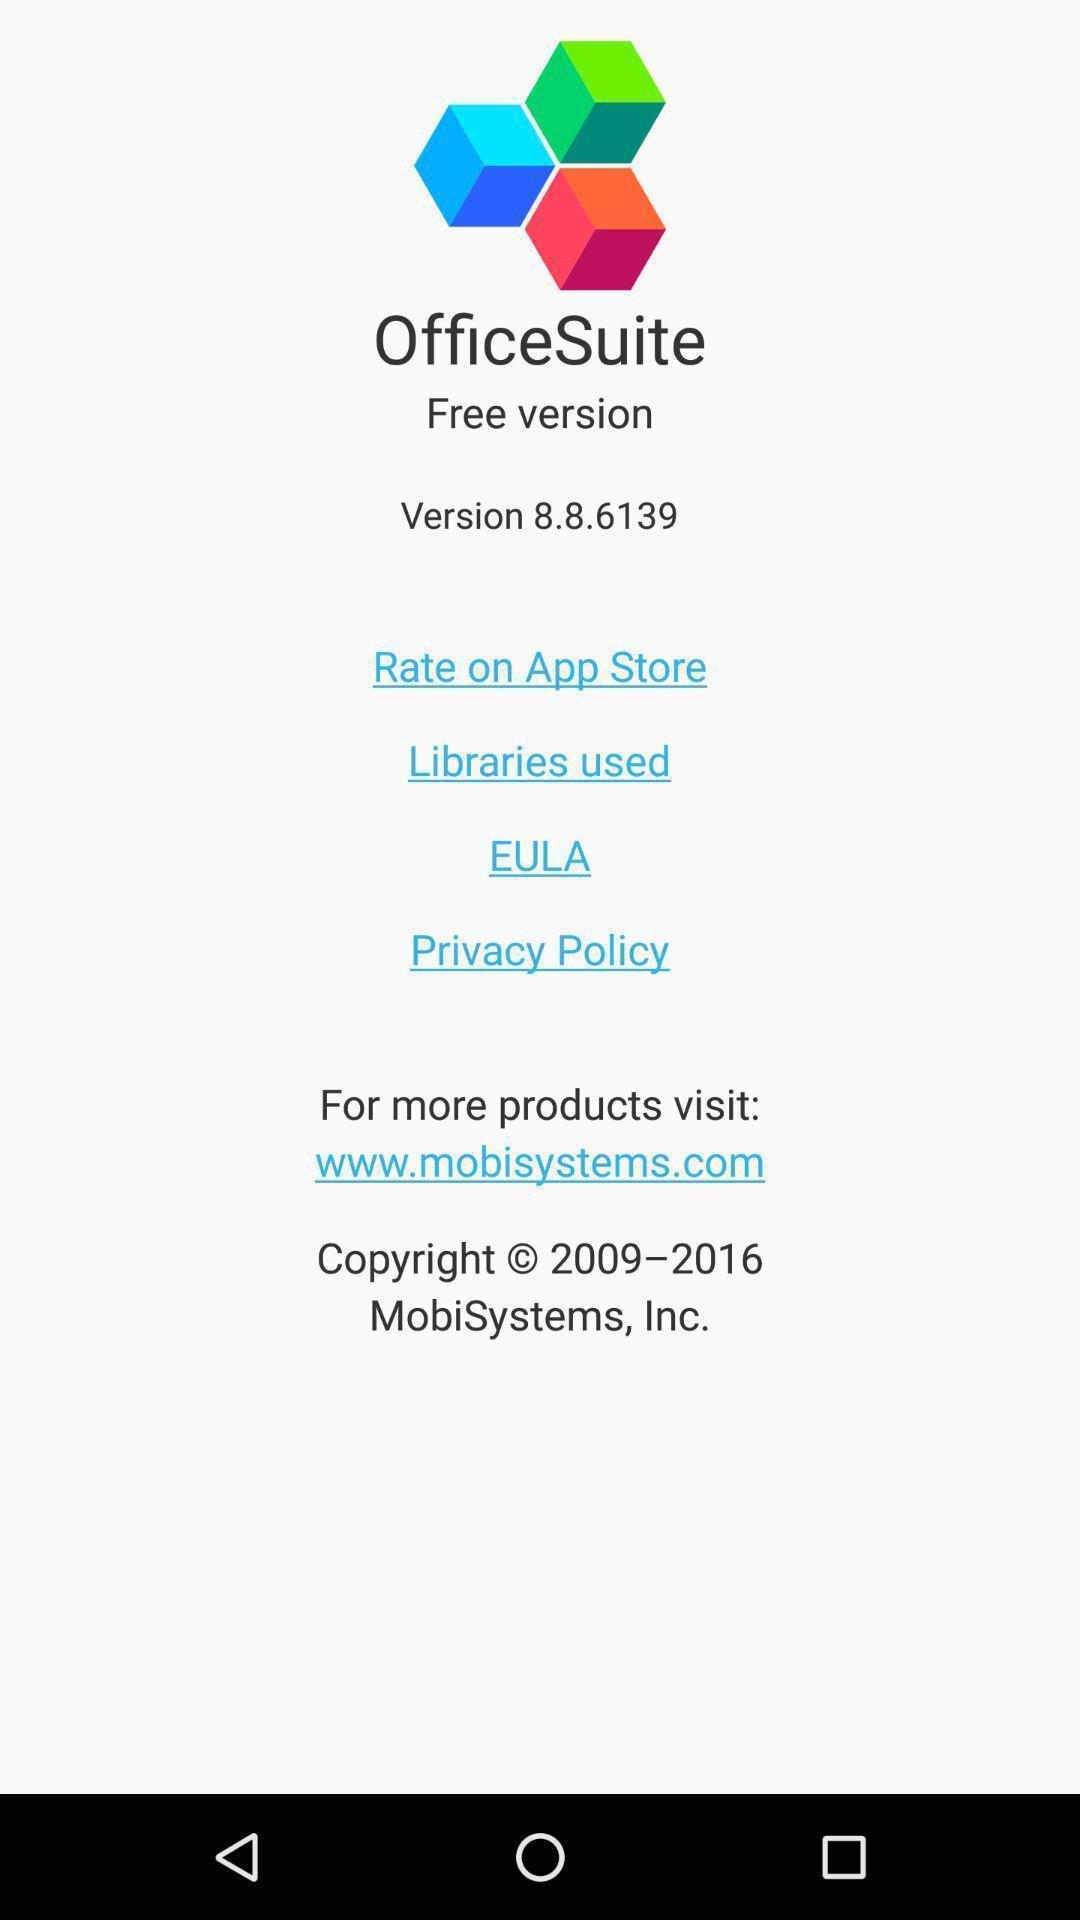Give me a summary of this screen capture. Welcome page for microsoft office app. 